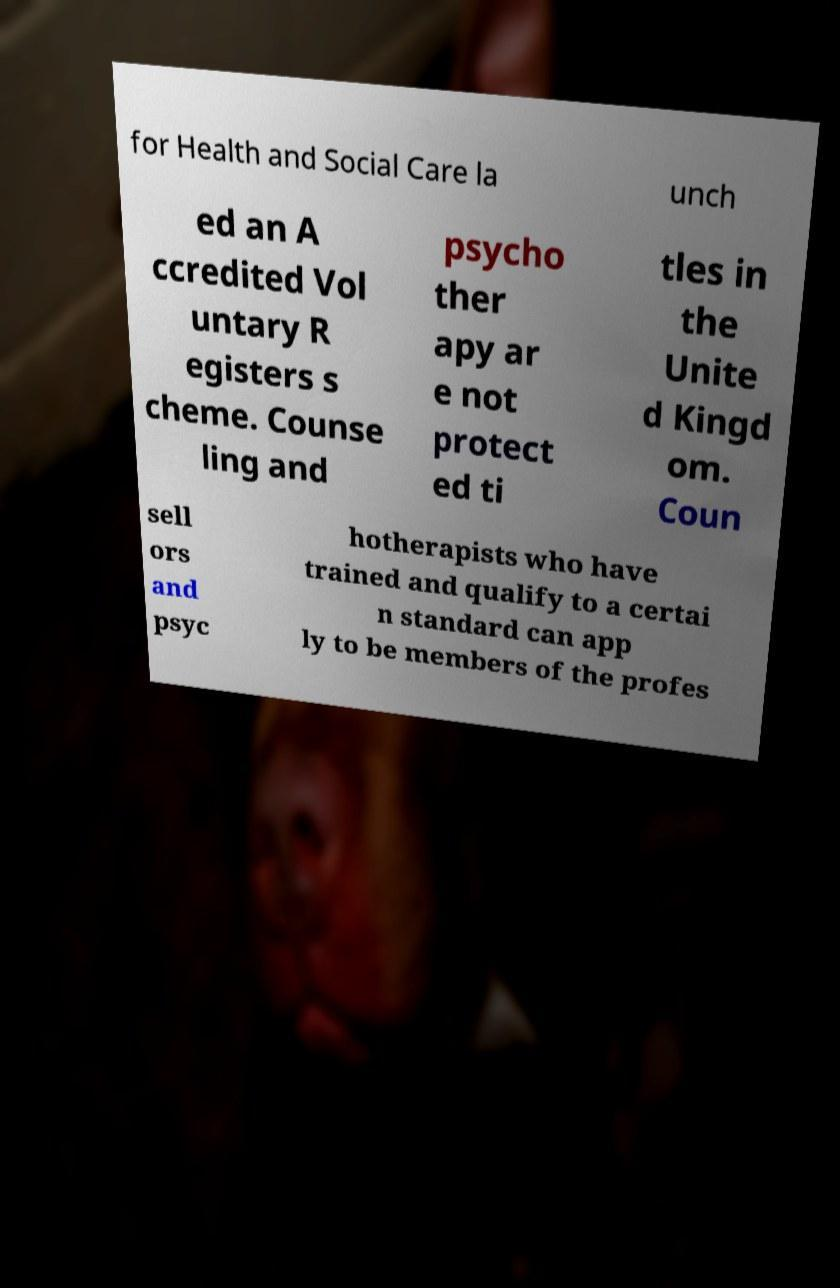Can you read and provide the text displayed in the image?This photo seems to have some interesting text. Can you extract and type it out for me? for Health and Social Care la unch ed an A ccredited Vol untary R egisters s cheme. Counse ling and psycho ther apy ar e not protect ed ti tles in the Unite d Kingd om. Coun sell ors and psyc hotherapists who have trained and qualify to a certai n standard can app ly to be members of the profes 